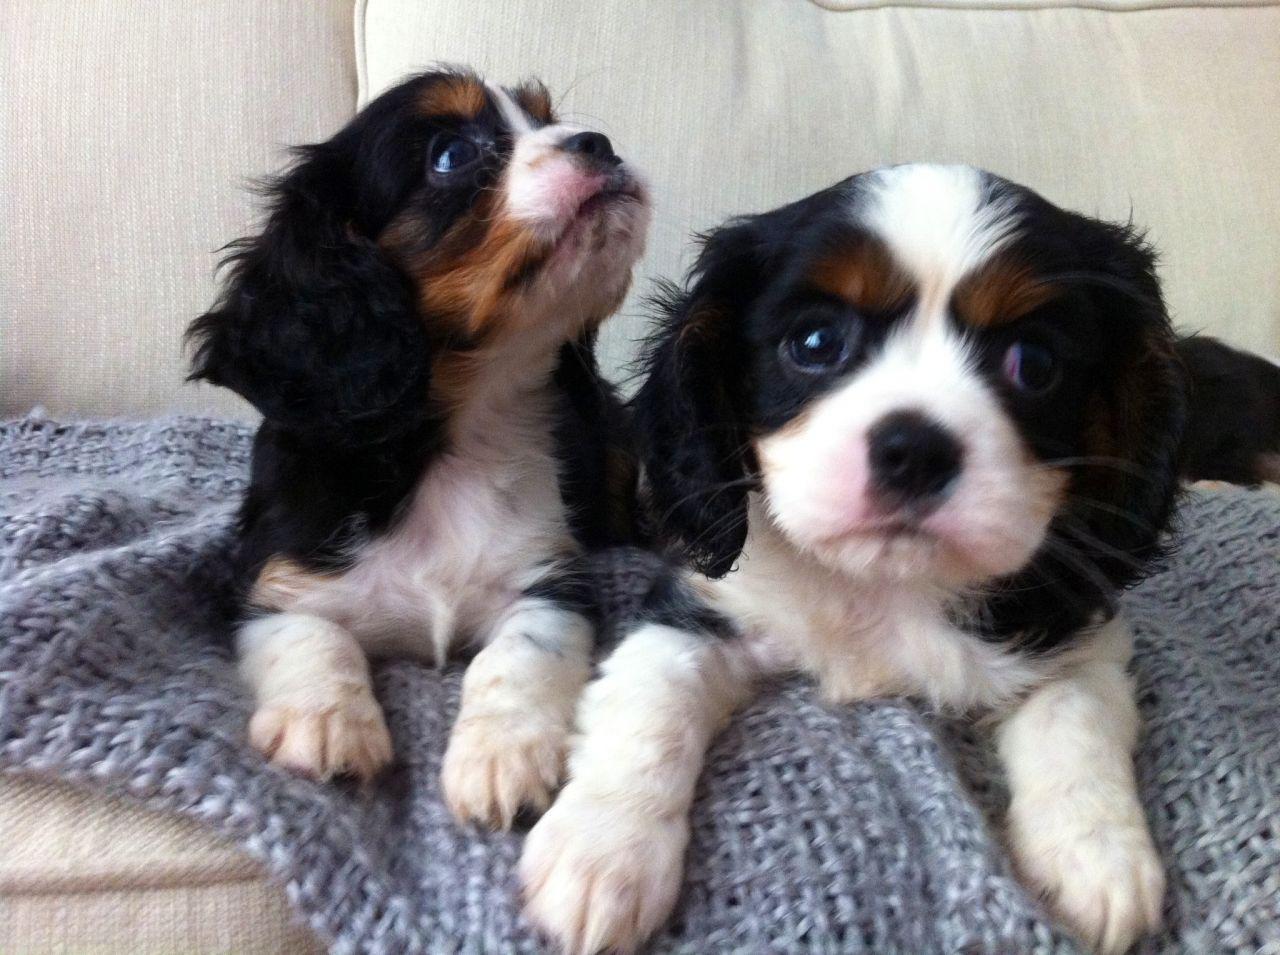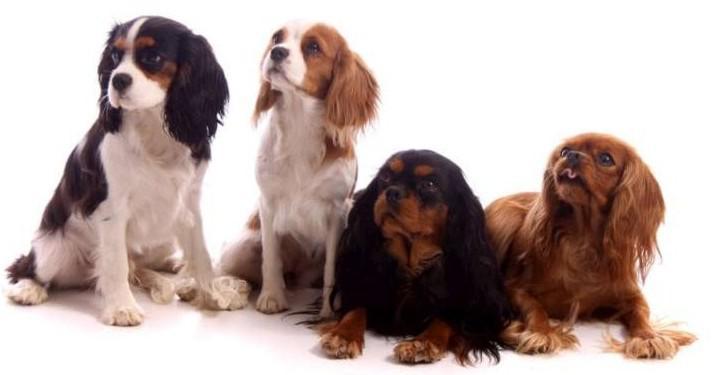The first image is the image on the left, the second image is the image on the right. Given the left and right images, does the statement "There are no less than six cocker spaniels" hold true? Answer yes or no. Yes. The first image is the image on the left, the second image is the image on the right. Assess this claim about the two images: "At least two dogs are lying down in the image on the right.". Correct or not? Answer yes or no. Yes. 